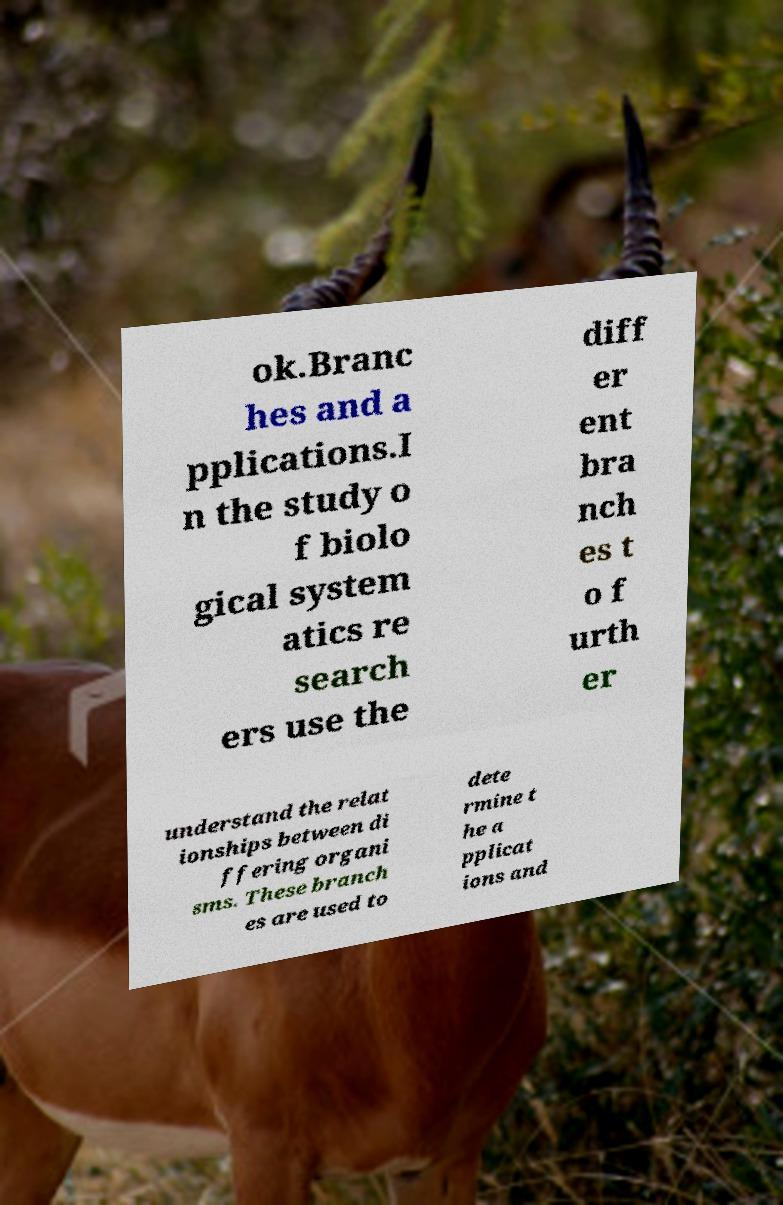I need the written content from this picture converted into text. Can you do that? ok.Branc hes and a pplications.I n the study o f biolo gical system atics re search ers use the diff er ent bra nch es t o f urth er understand the relat ionships between di ffering organi sms. These branch es are used to dete rmine t he a pplicat ions and 